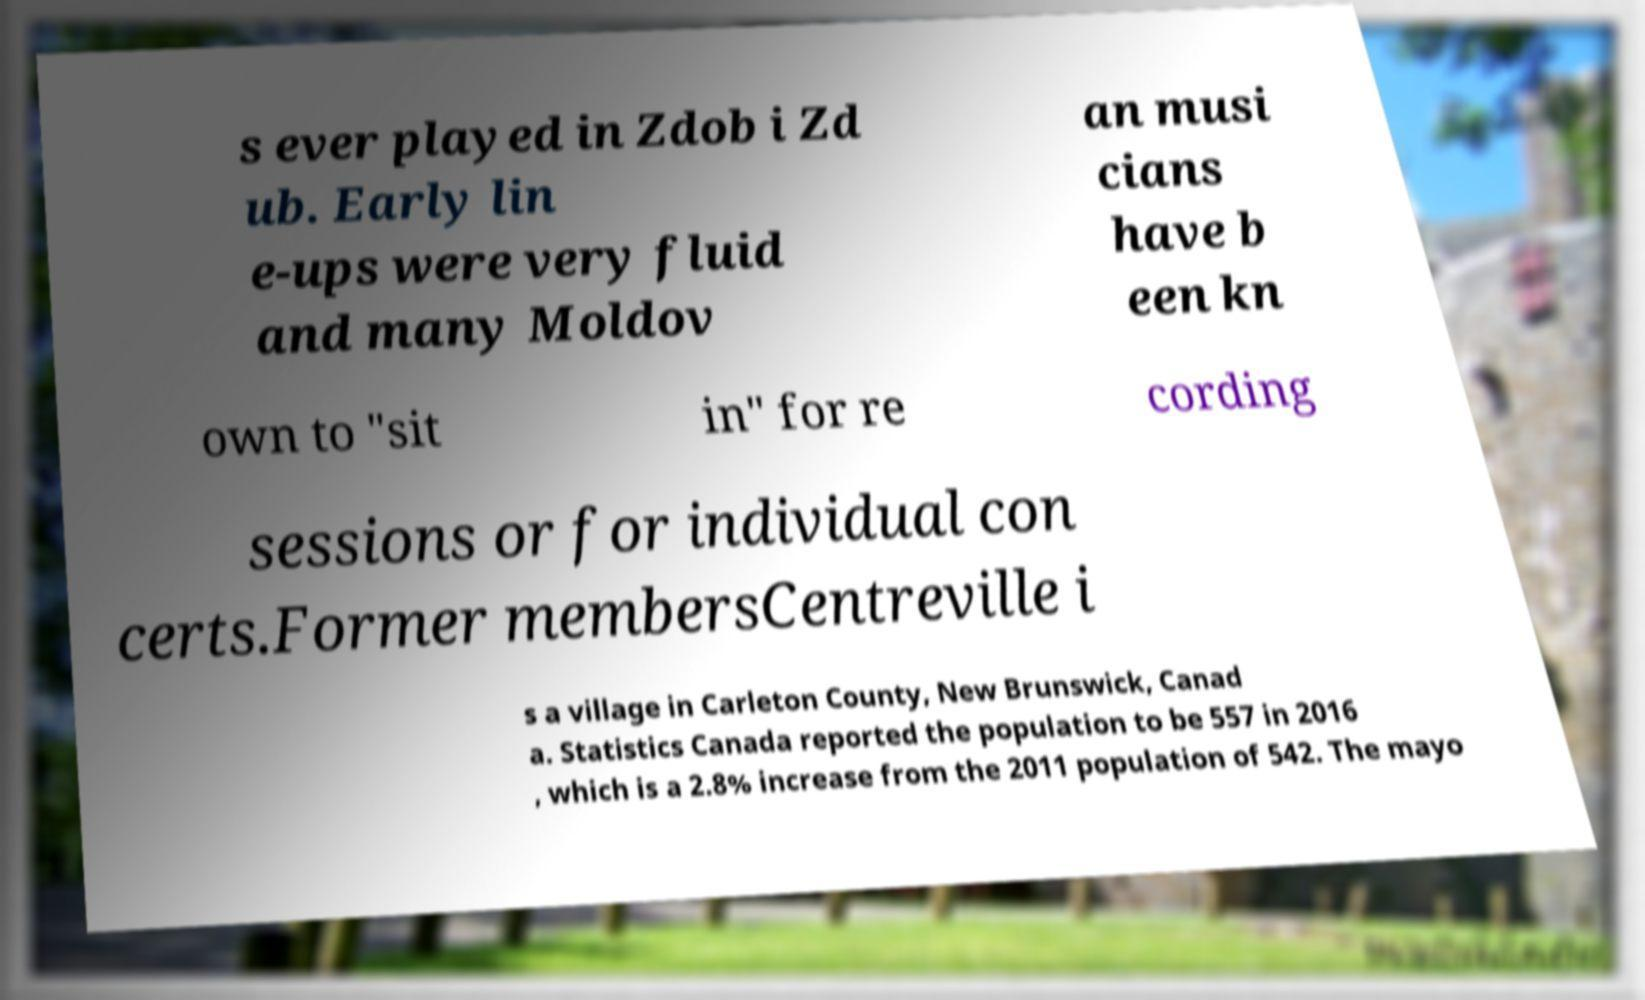What messages or text are displayed in this image? I need them in a readable, typed format. s ever played in Zdob i Zd ub. Early lin e-ups were very fluid and many Moldov an musi cians have b een kn own to "sit in" for re cording sessions or for individual con certs.Former membersCentreville i s a village in Carleton County, New Brunswick, Canad a. Statistics Canada reported the population to be 557 in 2016 , which is a 2.8% increase from the 2011 population of 542. The mayo 